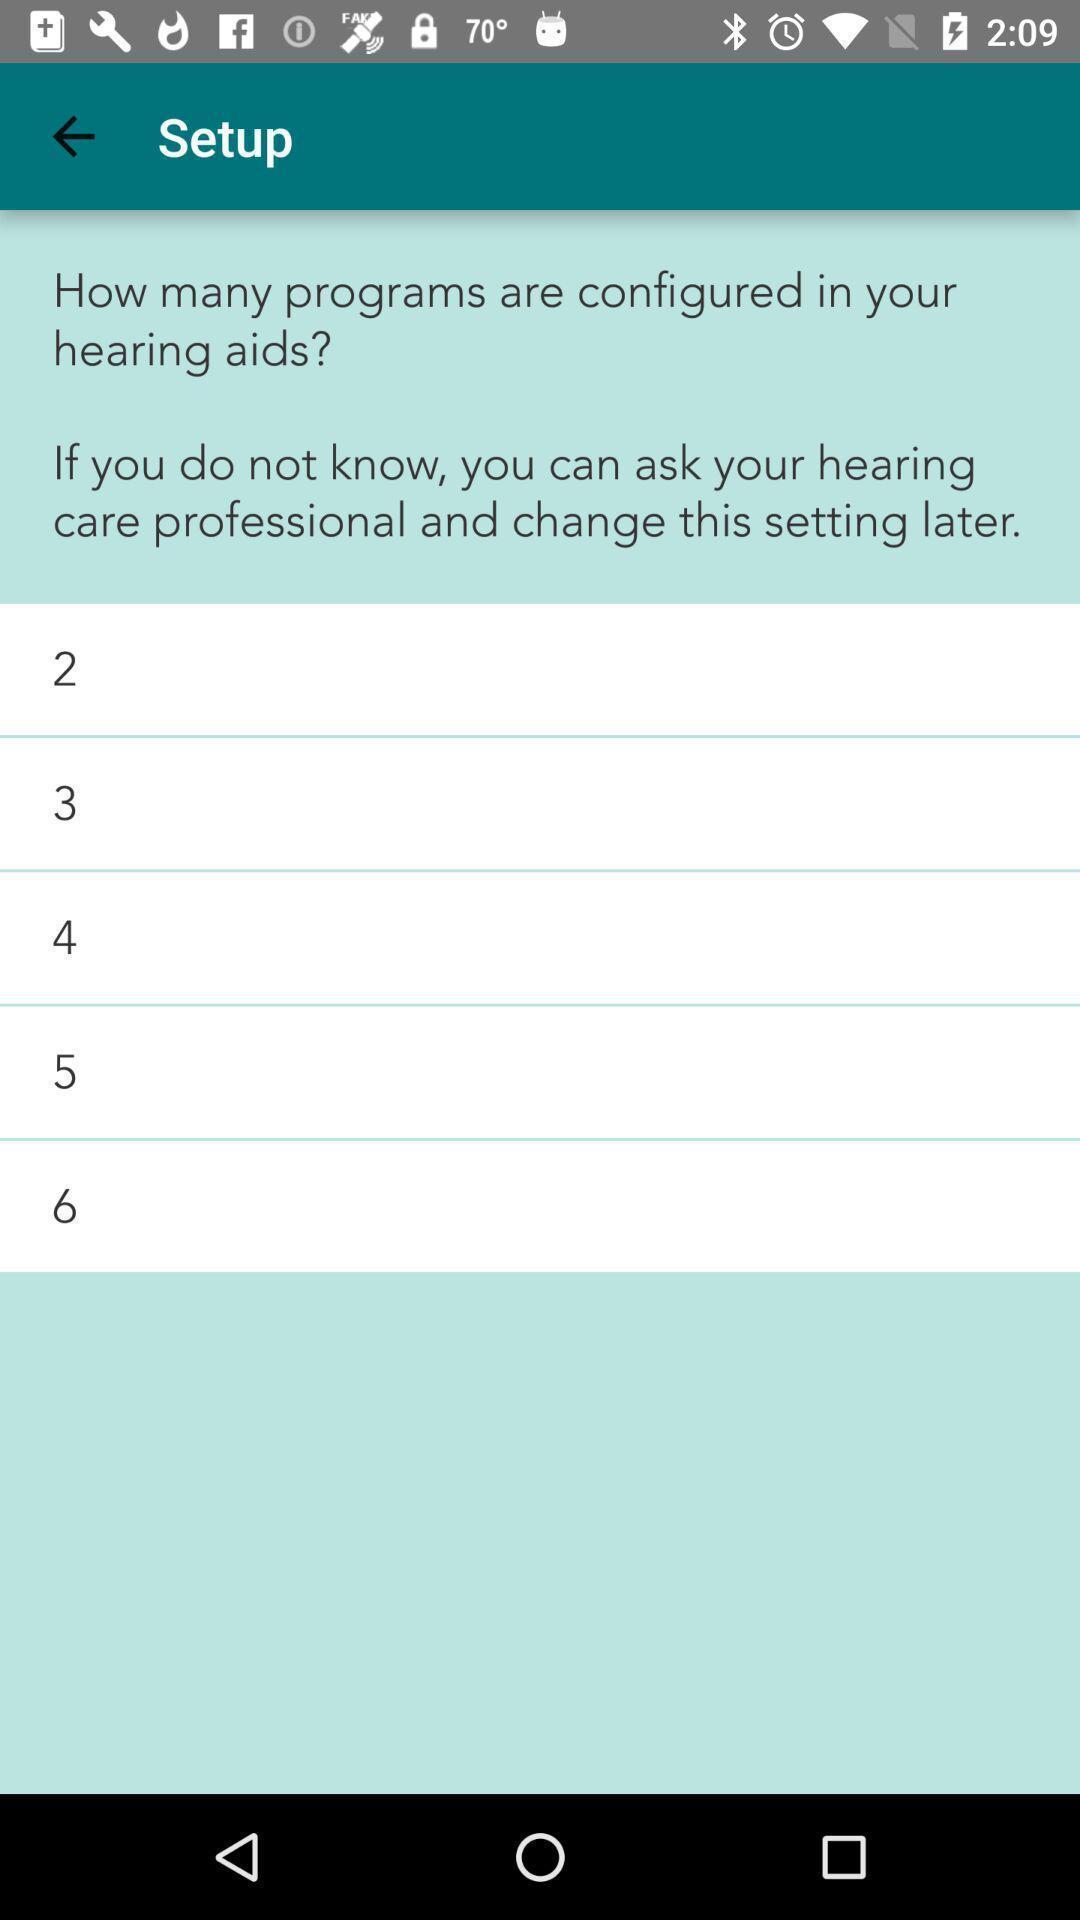Provide a detailed account of this screenshot. Page displaying the setup of setting options. 